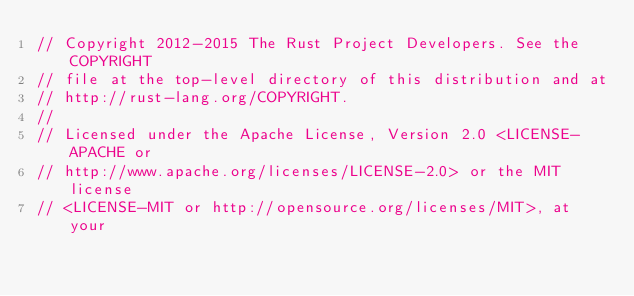<code> <loc_0><loc_0><loc_500><loc_500><_Rust_>// Copyright 2012-2015 The Rust Project Developers. See the COPYRIGHT
// file at the top-level directory of this distribution and at
// http://rust-lang.org/COPYRIGHT.
//
// Licensed under the Apache License, Version 2.0 <LICENSE-APACHE or
// http://www.apache.org/licenses/LICENSE-2.0> or the MIT license
// <LICENSE-MIT or http://opensource.org/licenses/MIT>, at your</code> 